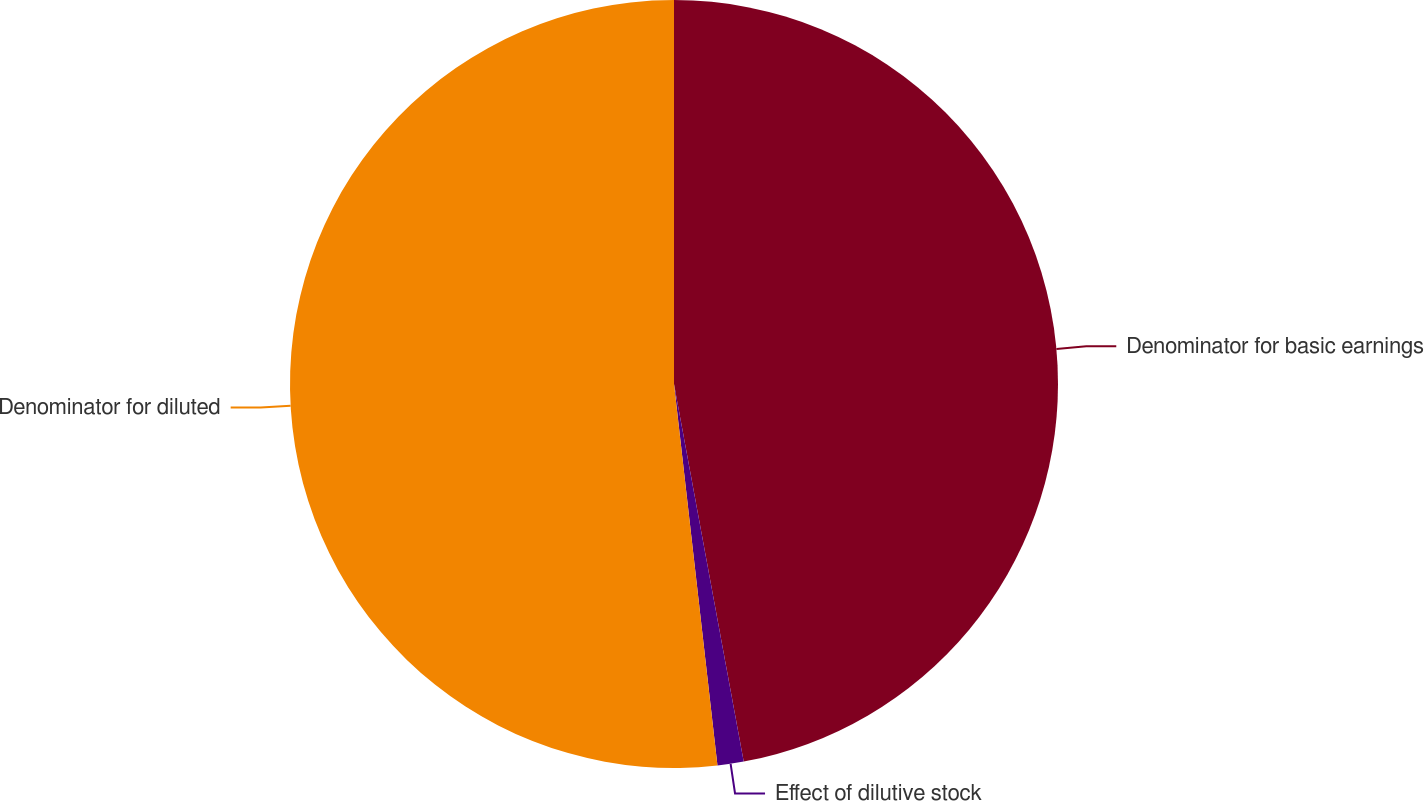Convert chart. <chart><loc_0><loc_0><loc_500><loc_500><pie_chart><fcel>Denominator for basic earnings<fcel>Effect of dilutive stock<fcel>Denominator for diluted<nl><fcel>47.09%<fcel>1.1%<fcel>51.8%<nl></chart> 